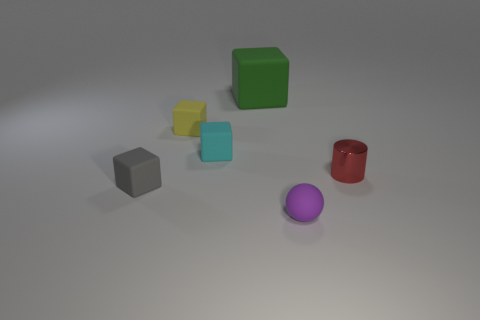Add 1 small gray blocks. How many objects exist? 7 Subtract all cyan cubes. How many cubes are left? 3 Subtract all cyan blocks. How many blocks are left? 3 Subtract 1 cubes. How many cubes are left? 3 Subtract all blue cylinders. How many green blocks are left? 1 Subtract all large gray matte cubes. Subtract all red cylinders. How many objects are left? 5 Add 1 green things. How many green things are left? 2 Add 3 tiny blocks. How many tiny blocks exist? 6 Subtract 0 green cylinders. How many objects are left? 6 Subtract all cubes. How many objects are left? 2 